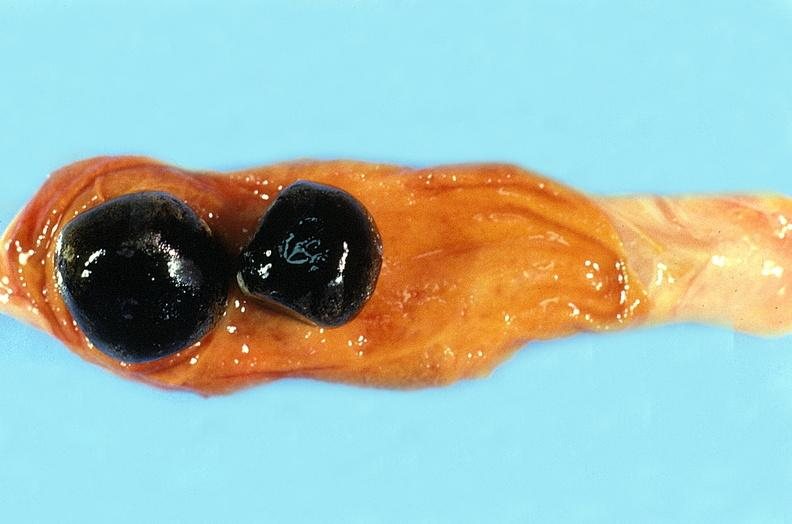what is present?
Answer the question using a single word or phrase. Urinary 